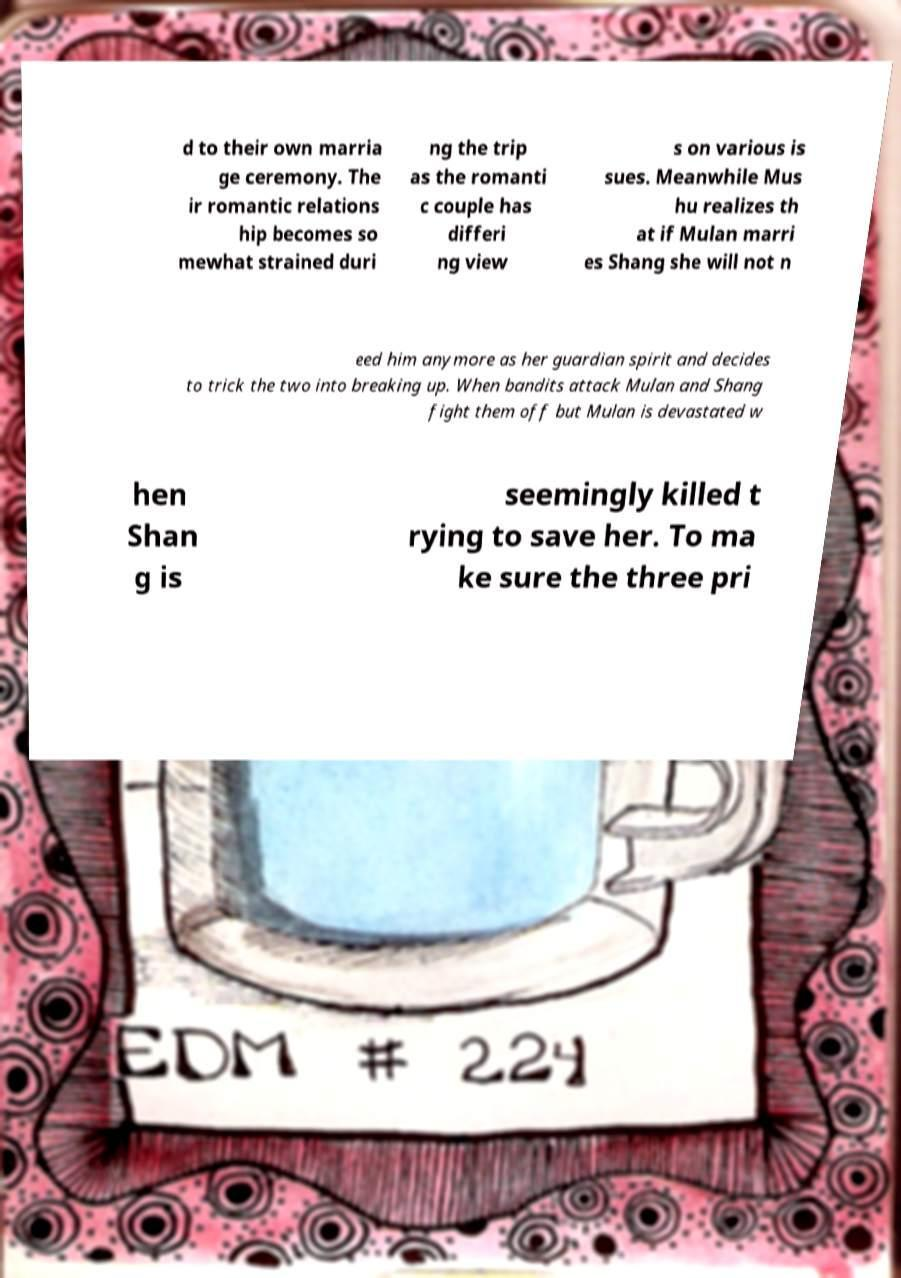Please identify and transcribe the text found in this image. d to their own marria ge ceremony. The ir romantic relations hip becomes so mewhat strained duri ng the trip as the romanti c couple has differi ng view s on various is sues. Meanwhile Mus hu realizes th at if Mulan marri es Shang she will not n eed him anymore as her guardian spirit and decides to trick the two into breaking up. When bandits attack Mulan and Shang fight them off but Mulan is devastated w hen Shan g is seemingly killed t rying to save her. To ma ke sure the three pri 